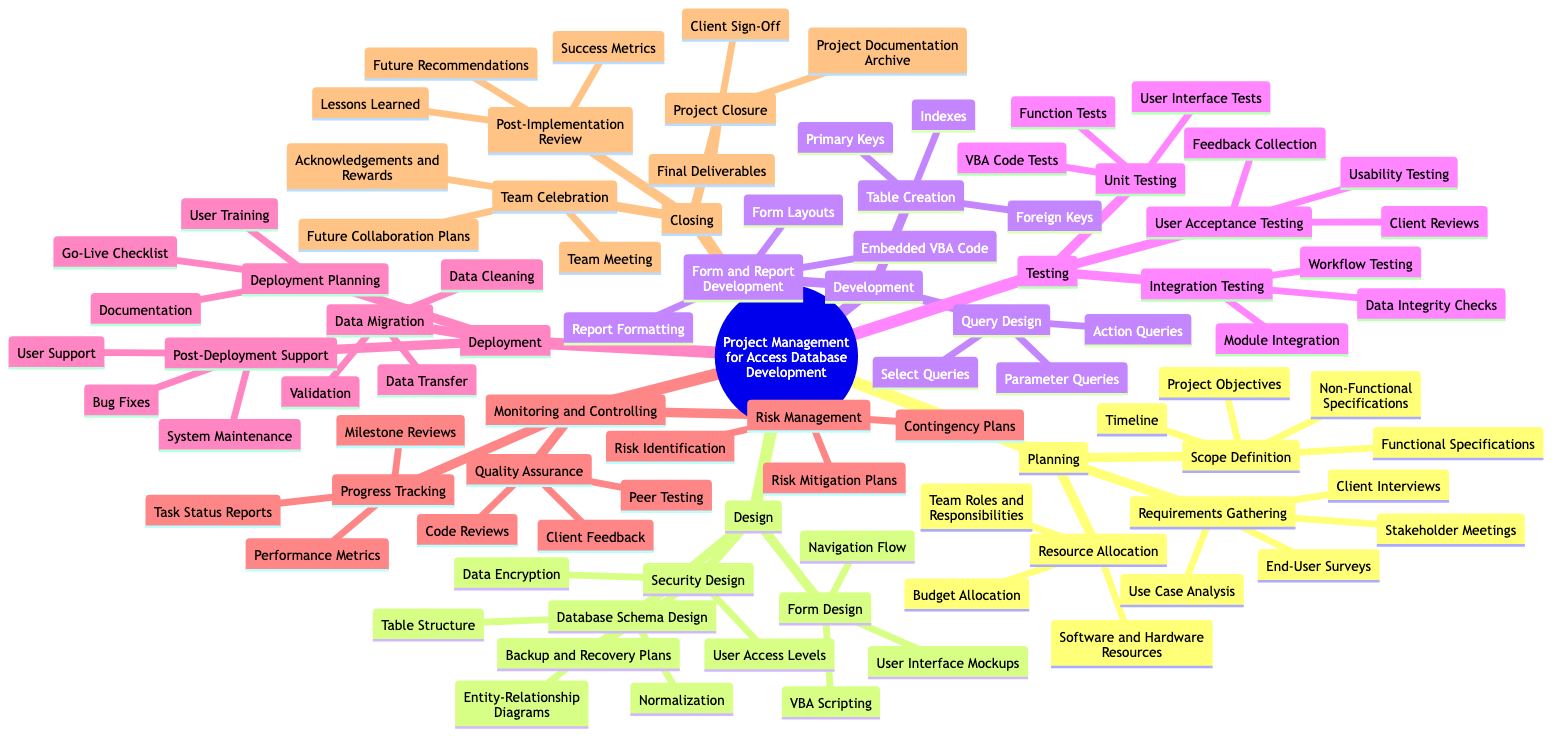What is the first task listed under Planning? The diagram shows "Requirements Gathering" as the first task listed under the "Planning" section, which includes various subtasks related to collecting information from clients and stakeholders.
Answer: Requirements Gathering How many main sections are present in the diagram? By counting the top-level nodes in the diagram, we can see that there are six main sections: Planning, Design, Development, Testing, Deployment, Monitoring and Controlling, and Closing.
Answer: 6 What are the main tasks under the Design section? The Design section of the diagram contains three main tasks: Database Schema Design, Form Design, and Security Design.
Answer: Database Schema Design, Form Design, Security Design Which task includes User Training as a subtask? The Deployment Planning task, which is under the Deployment section, includes User Training as a subtask along with the Go-Live Checklist and Documentation.
Answer: Deployment Planning What is the main objective of the Post-Implementation Review? The Post-Implementation Review aims for capturing "Lessons Learned," which helps in assessing the project outcomes and establishing future recommendations.
Answer: Lessons Learned Which step directly follows Unit Testing? According to the diagram, after Unit Testing, the next step is Integration Testing, which involves testing how various modules work together.
Answer: Integration Testing What are the components of Risk Management? There are three components in the Risk Management section: Risk Identification, Risk Mitigation Plans, and Contingency Plans, all of which help in addressing potential project risks.
Answer: Risk Identification, Risk Mitigation Plans, Contingency Plans How many subtasks are listed under Team Celebration? The Team Celebration task has three subtasks: Team Meeting, Acknowledgements and Rewards, and Future Collaboration Plans, making it three in total.
Answer: 3 Which task includes feedback collection as a subtask? Feedback Collection is included as a subtask under the User Acceptance Testing task, which is part of the Testing phase of the project.
Answer: User Acceptance Testing 